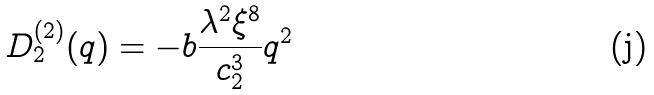Convert formula to latex. <formula><loc_0><loc_0><loc_500><loc_500>D _ { 2 } ^ { ( 2 ) } ( q ) = - b \frac { \lambda ^ { 2 } \xi ^ { 8 } } { c _ { 2 } ^ { 3 } } q ^ { 2 }</formula> 